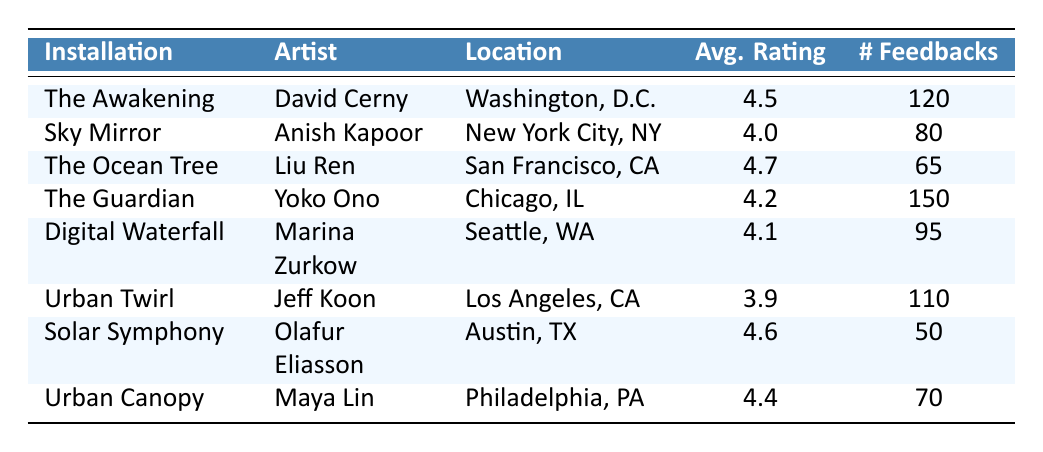What is the average rating of "The Ocean Tree"? The average rating for "The Ocean Tree" is provided directly in the table, which shows it as 4.7.
Answer: 4.7 Which installation received the most feedback? The installation with the highest number of feedbacks is "The Guardian," which has 150 feedbacks.
Answer: The Guardian How many installations have an average rating above 4.5? Checking the ratings, "The Ocean Tree" (4.7), "Solar Symphony" (4.6), and "The Awakening" (4.5) are above 4.5, making a total of 3 installations.
Answer: 3 What is the total number of feedbacks for all installations? By adding the number of feedbacks together: 120 + 80 + 65 + 150 + 95 + 110 + 50 + 70 = 800. Hence, the total is 800.
Answer: 800 Is there any installation with an average rating below 4.0? "Urban Twirl" has an average rating of 3.9, which is below 4.0, confirming that there is at least one such installation.
Answer: Yes What is the difference in average ratings between "The Ocean Tree" and "Sky Mirror"? The average rating of "The Ocean Tree" is 4.7, and that of "Sky Mirror" is 4.0. The difference is 4.7 - 4.0 = 0.7.
Answer: 0.7 Which artist created the installation with the lowest average rating? "Urban Twirl" has the lowest average rating of 3.9, created by Jeff Koon, identifying him as the artist with the lowest-rated installation.
Answer: Jeff Koon How many installations are located in California? The table lists "The Ocean Tree" in San Francisco and "Solar Symphony" in Austin, totaling 2 installations in California.
Answer: 2 If you sum the average ratings of "Digital Waterfall" and "Urban Canopy," what do you get? The average rating of "Digital Waterfall" is 4.1, and "Urban Canopy" is 4.4. Summing these gives 4.1 + 4.4 = 8.5.
Answer: 8.5 Which installation is located in Washington, D.C.? The table indicates that "The Awakening" is located in Washington, D.C. This information is directly retrievable.
Answer: The Awakening 